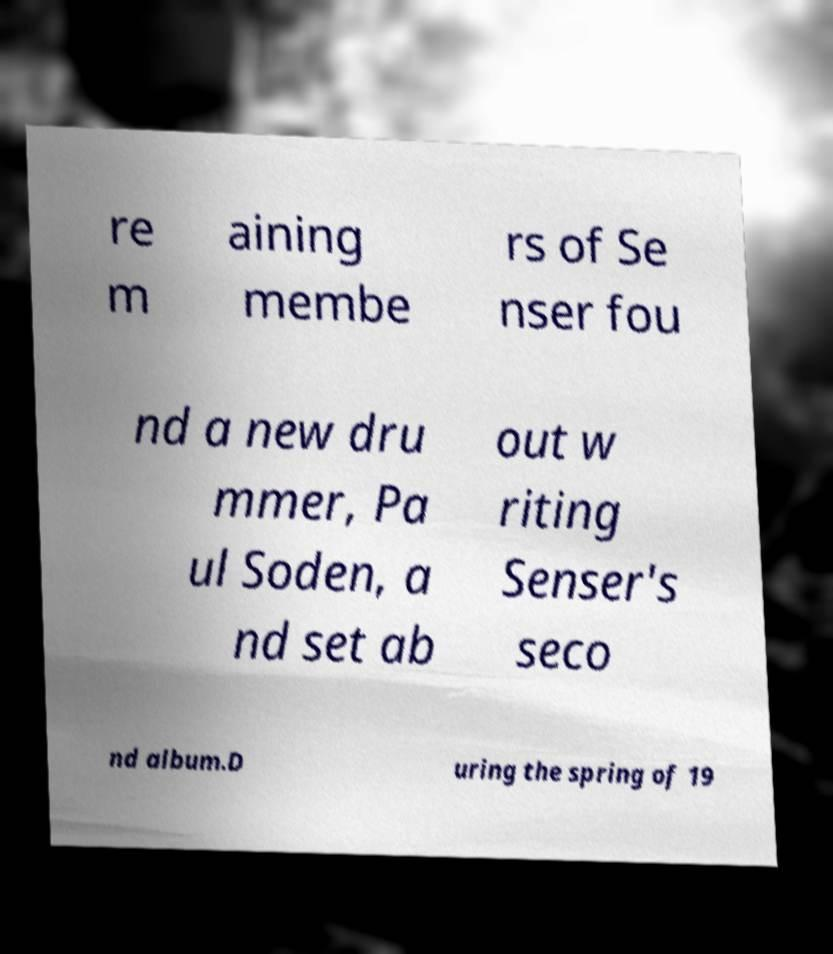Please read and relay the text visible in this image. What does it say? re m aining membe rs of Se nser fou nd a new dru mmer, Pa ul Soden, a nd set ab out w riting Senser's seco nd album.D uring the spring of 19 